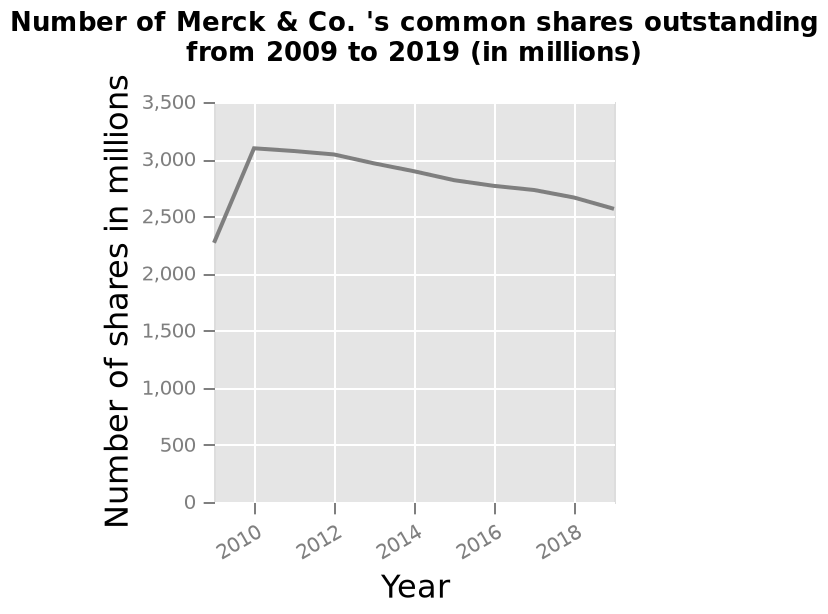<image>
please summary the statistics and relations of the chart There is a steady increase in shares per million from 2, 400  in 2009 to 2,100 in 2010. They remained fairly steady up to 2012 where a downard trend can be observed. By 2019 shares were going down to 2,500. 